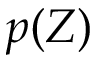Convert formula to latex. <formula><loc_0><loc_0><loc_500><loc_500>p ( Z )</formula> 